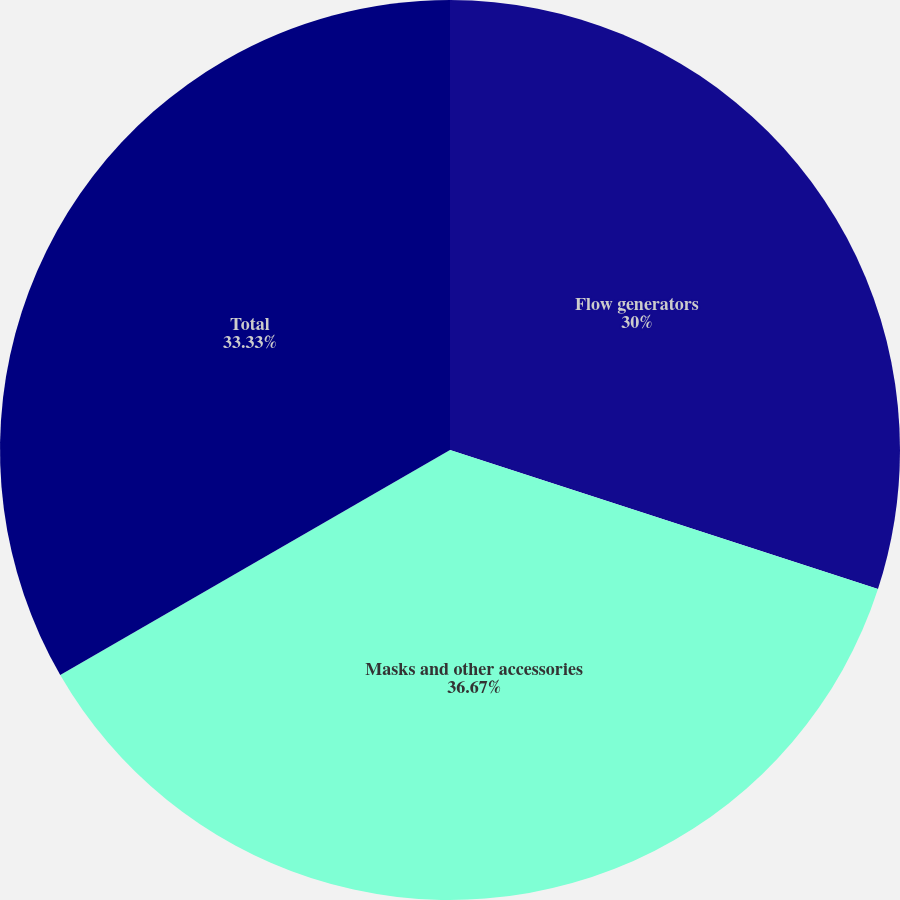<chart> <loc_0><loc_0><loc_500><loc_500><pie_chart><fcel>Flow generators<fcel>Masks and other accessories<fcel>Total<nl><fcel>30.0%<fcel>36.67%<fcel>33.33%<nl></chart> 